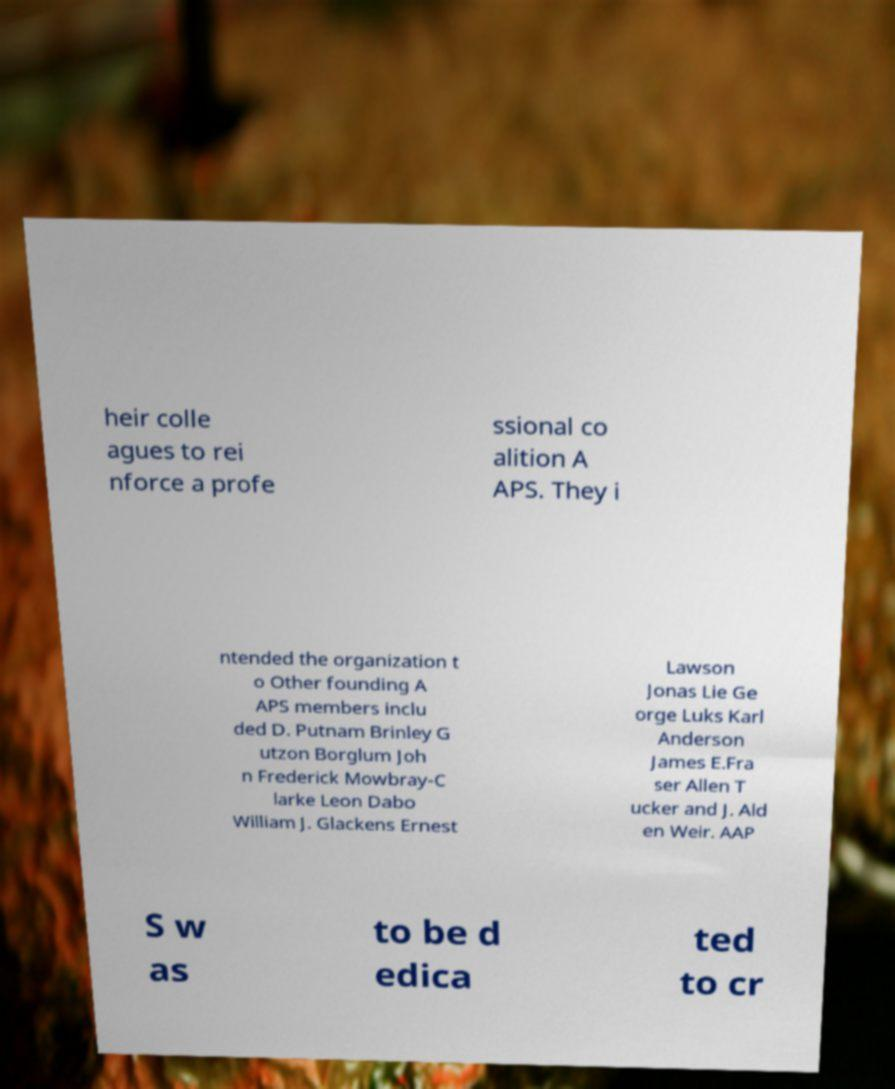Could you assist in decoding the text presented in this image and type it out clearly? heir colle agues to rei nforce a profe ssional co alition A APS. They i ntended the organization t o Other founding A APS members inclu ded D. Putnam Brinley G utzon Borglum Joh n Frederick Mowbray-C larke Leon Dabo William J. Glackens Ernest Lawson Jonas Lie Ge orge Luks Karl Anderson James E.Fra ser Allen T ucker and J. Ald en Weir. AAP S w as to be d edica ted to cr 